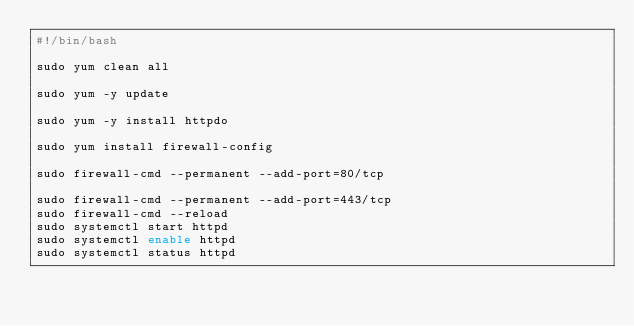<code> <loc_0><loc_0><loc_500><loc_500><_Bash_>#!/bin/bash

sudo yum clean all

sudo yum -y update

sudo yum -y install httpdo

sudo yum install firewall-config

sudo firewall-cmd --permanent --add-port=80/tcp

sudo firewall-cmd --permanent --add-port=443/tcp
sudo firewall-cmd --reload
sudo systemctl start httpd
sudo systemctl enable httpd
sudo systemctl status httpd
</code> 